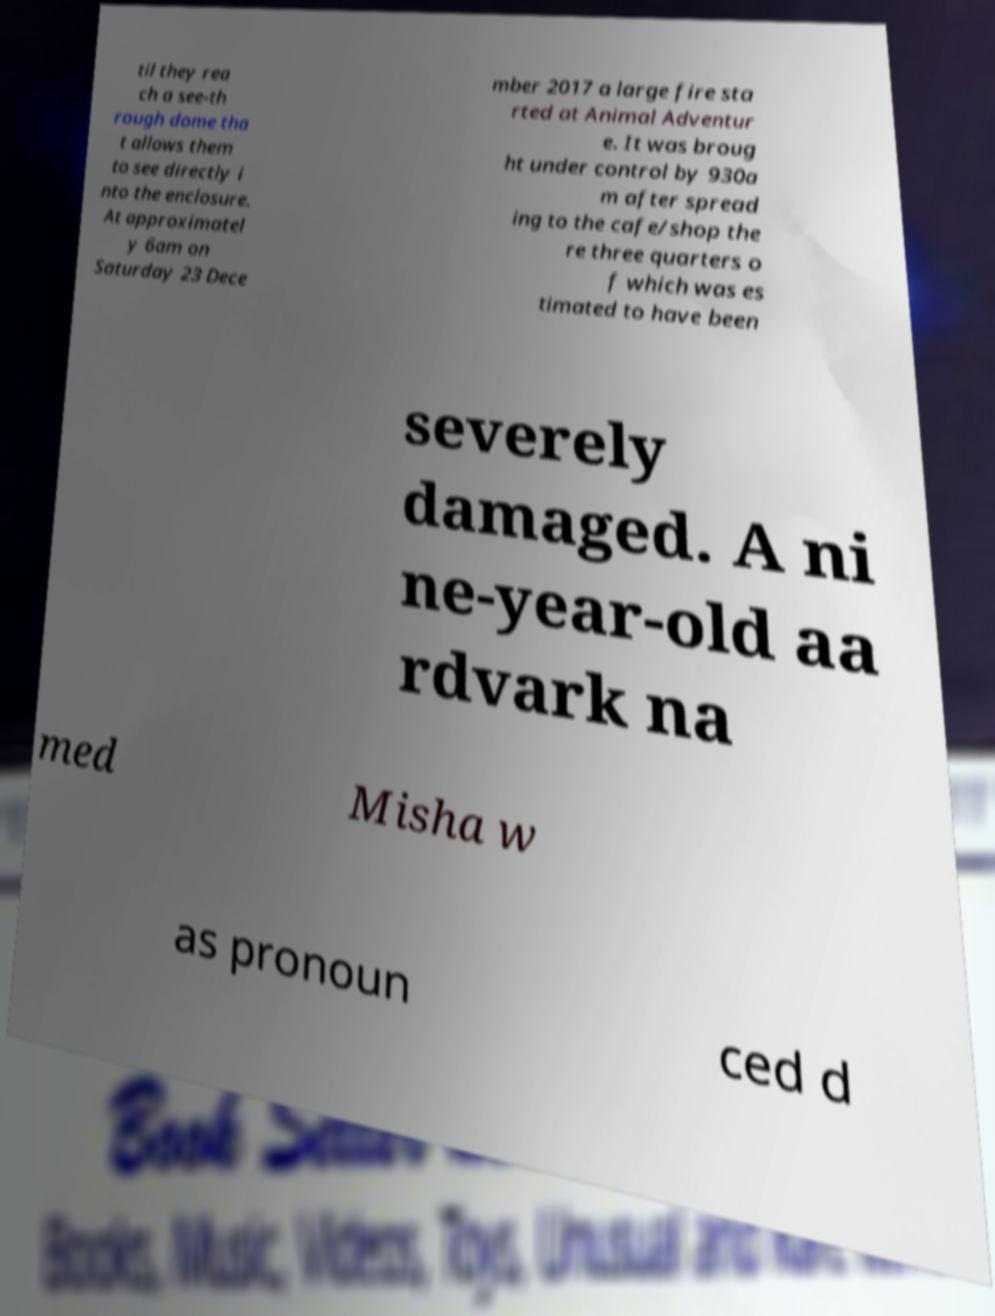What messages or text are displayed in this image? I need them in a readable, typed format. til they rea ch a see-th rough dome tha t allows them to see directly i nto the enclosure. At approximatel y 6am on Saturday 23 Dece mber 2017 a large fire sta rted at Animal Adventur e. It was broug ht under control by 930a m after spread ing to the cafe/shop the re three quarters o f which was es timated to have been severely damaged. A ni ne-year-old aa rdvark na med Misha w as pronoun ced d 